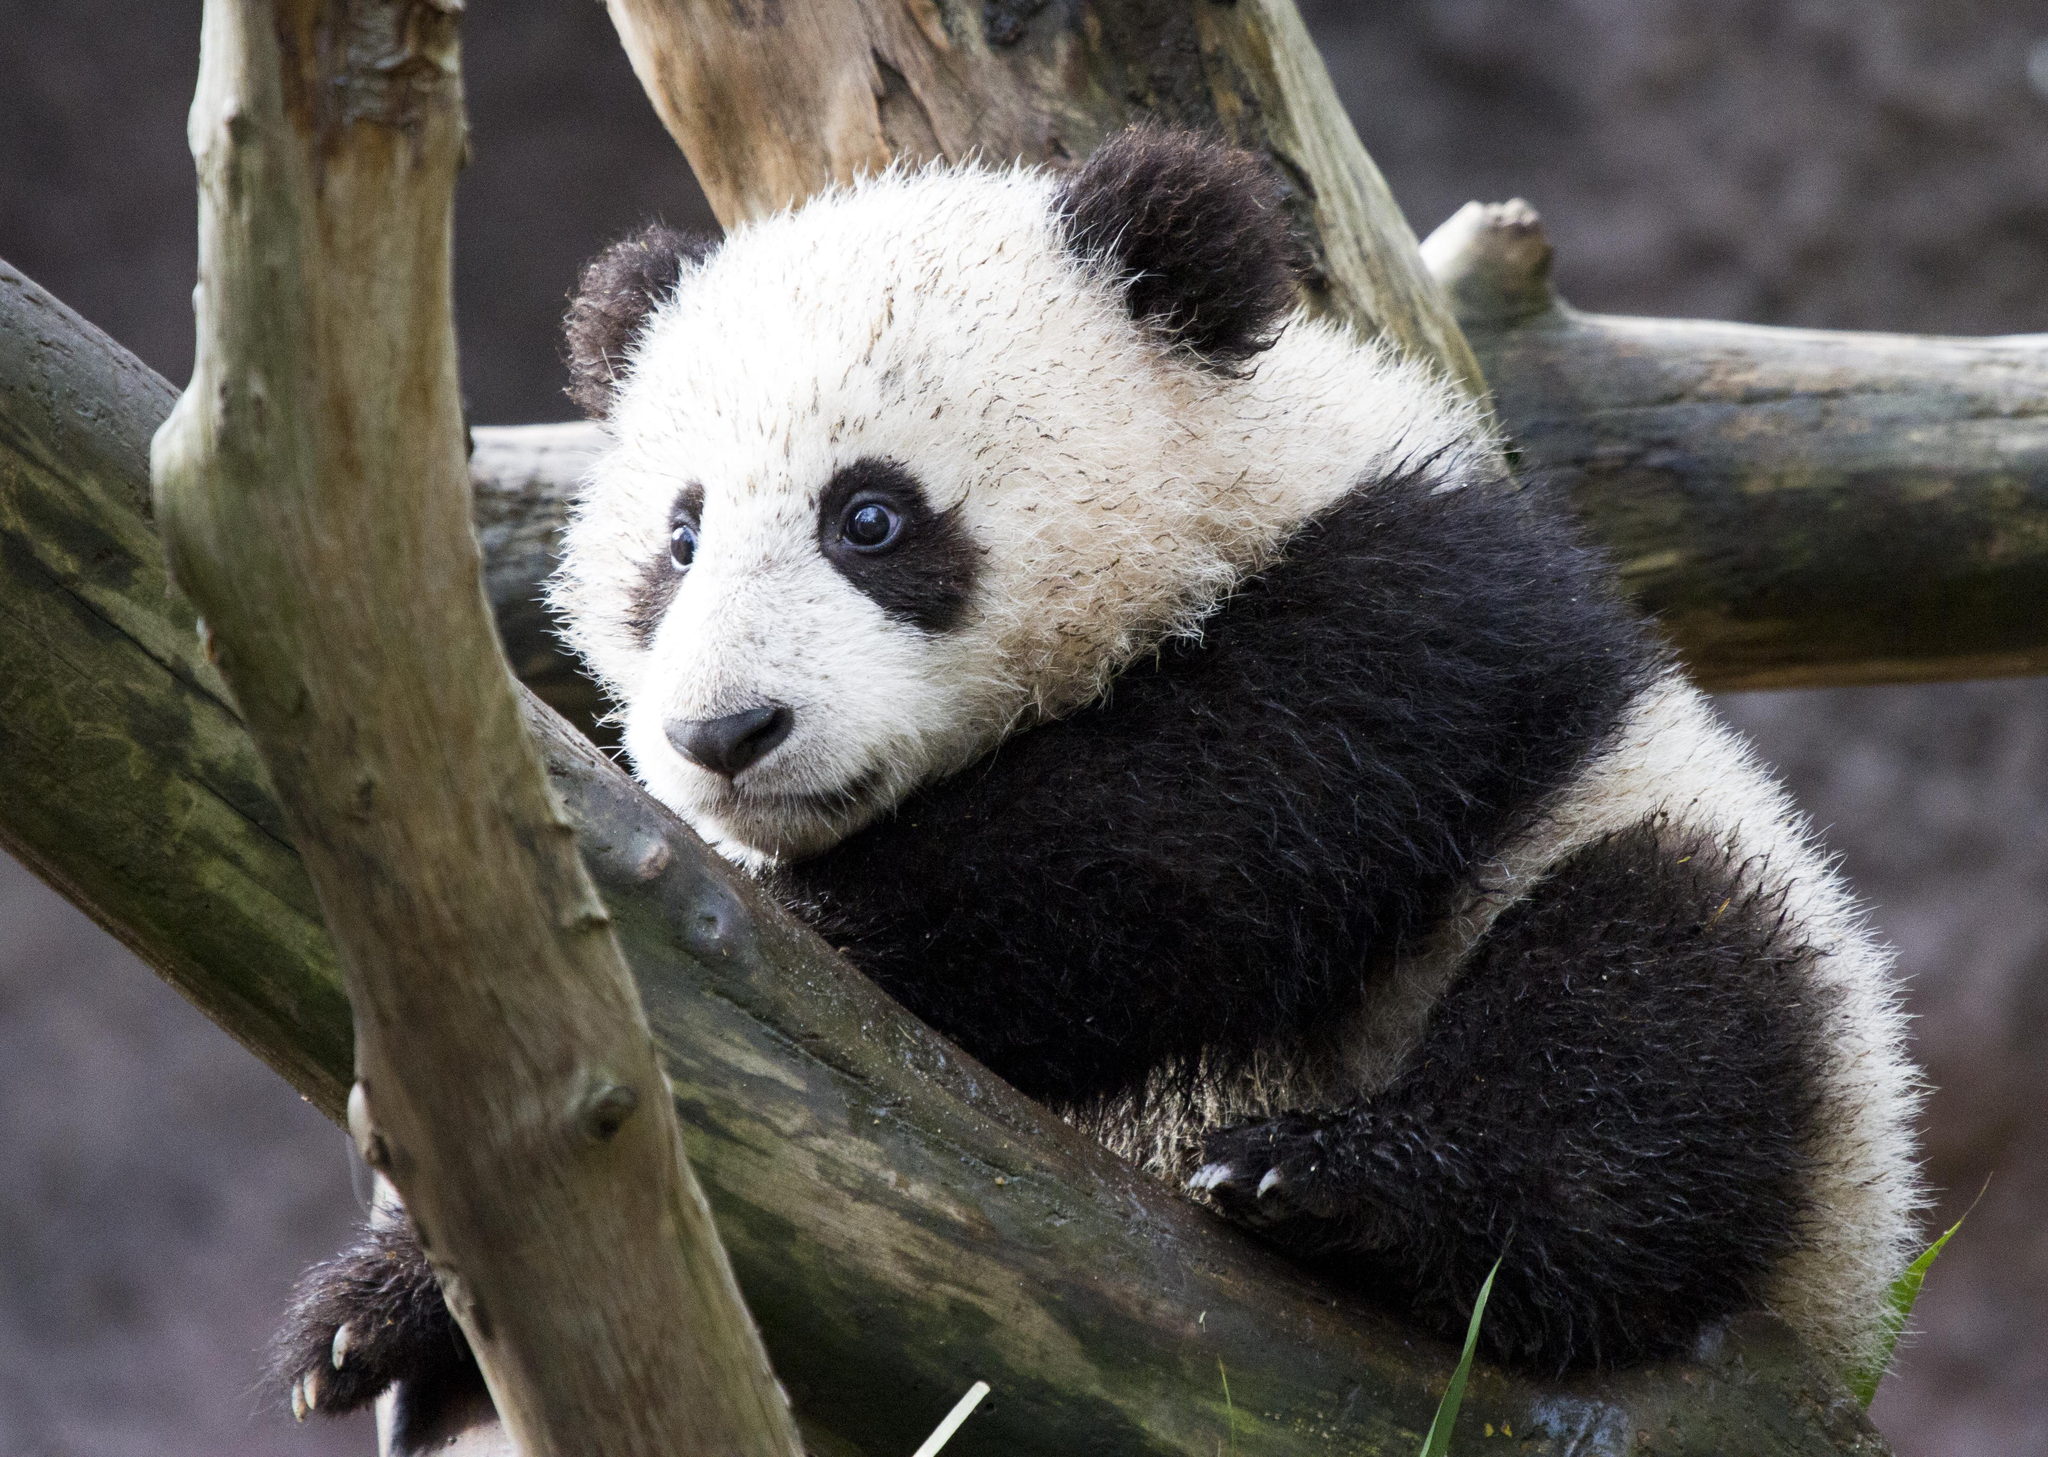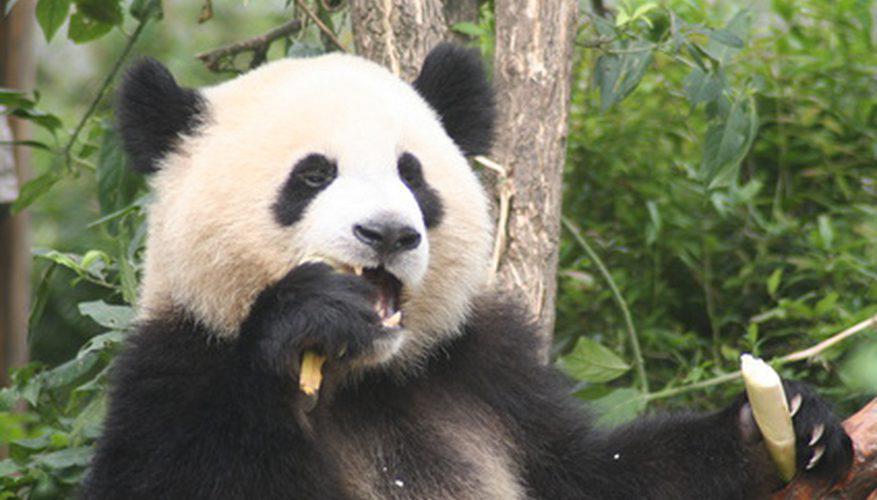The first image is the image on the left, the second image is the image on the right. For the images displayed, is the sentence "a panda is eating bamboo" factually correct? Answer yes or no. Yes. The first image is the image on the left, the second image is the image on the right. For the images shown, is this caption "One panda is eating bamboo." true? Answer yes or no. Yes. 